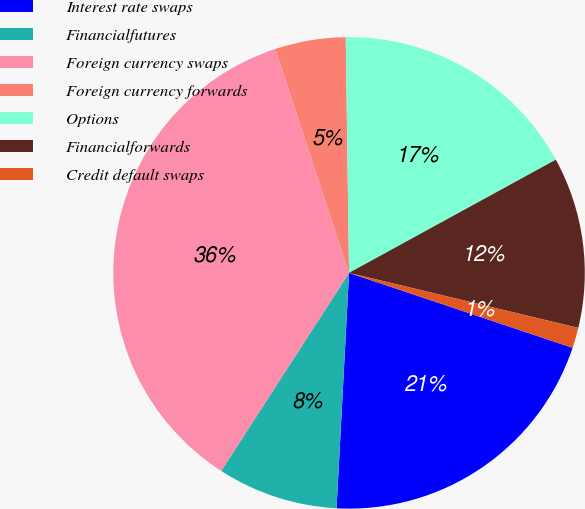Convert chart to OTSL. <chart><loc_0><loc_0><loc_500><loc_500><pie_chart><fcel>Interest rate swaps<fcel>Financialfutures<fcel>Foreign currency swaps<fcel>Foreign currency forwards<fcel>Options<fcel>Financialforwards<fcel>Credit default swaps<nl><fcel>20.69%<fcel>8.28%<fcel>35.81%<fcel>4.84%<fcel>17.25%<fcel>11.72%<fcel>1.4%<nl></chart> 